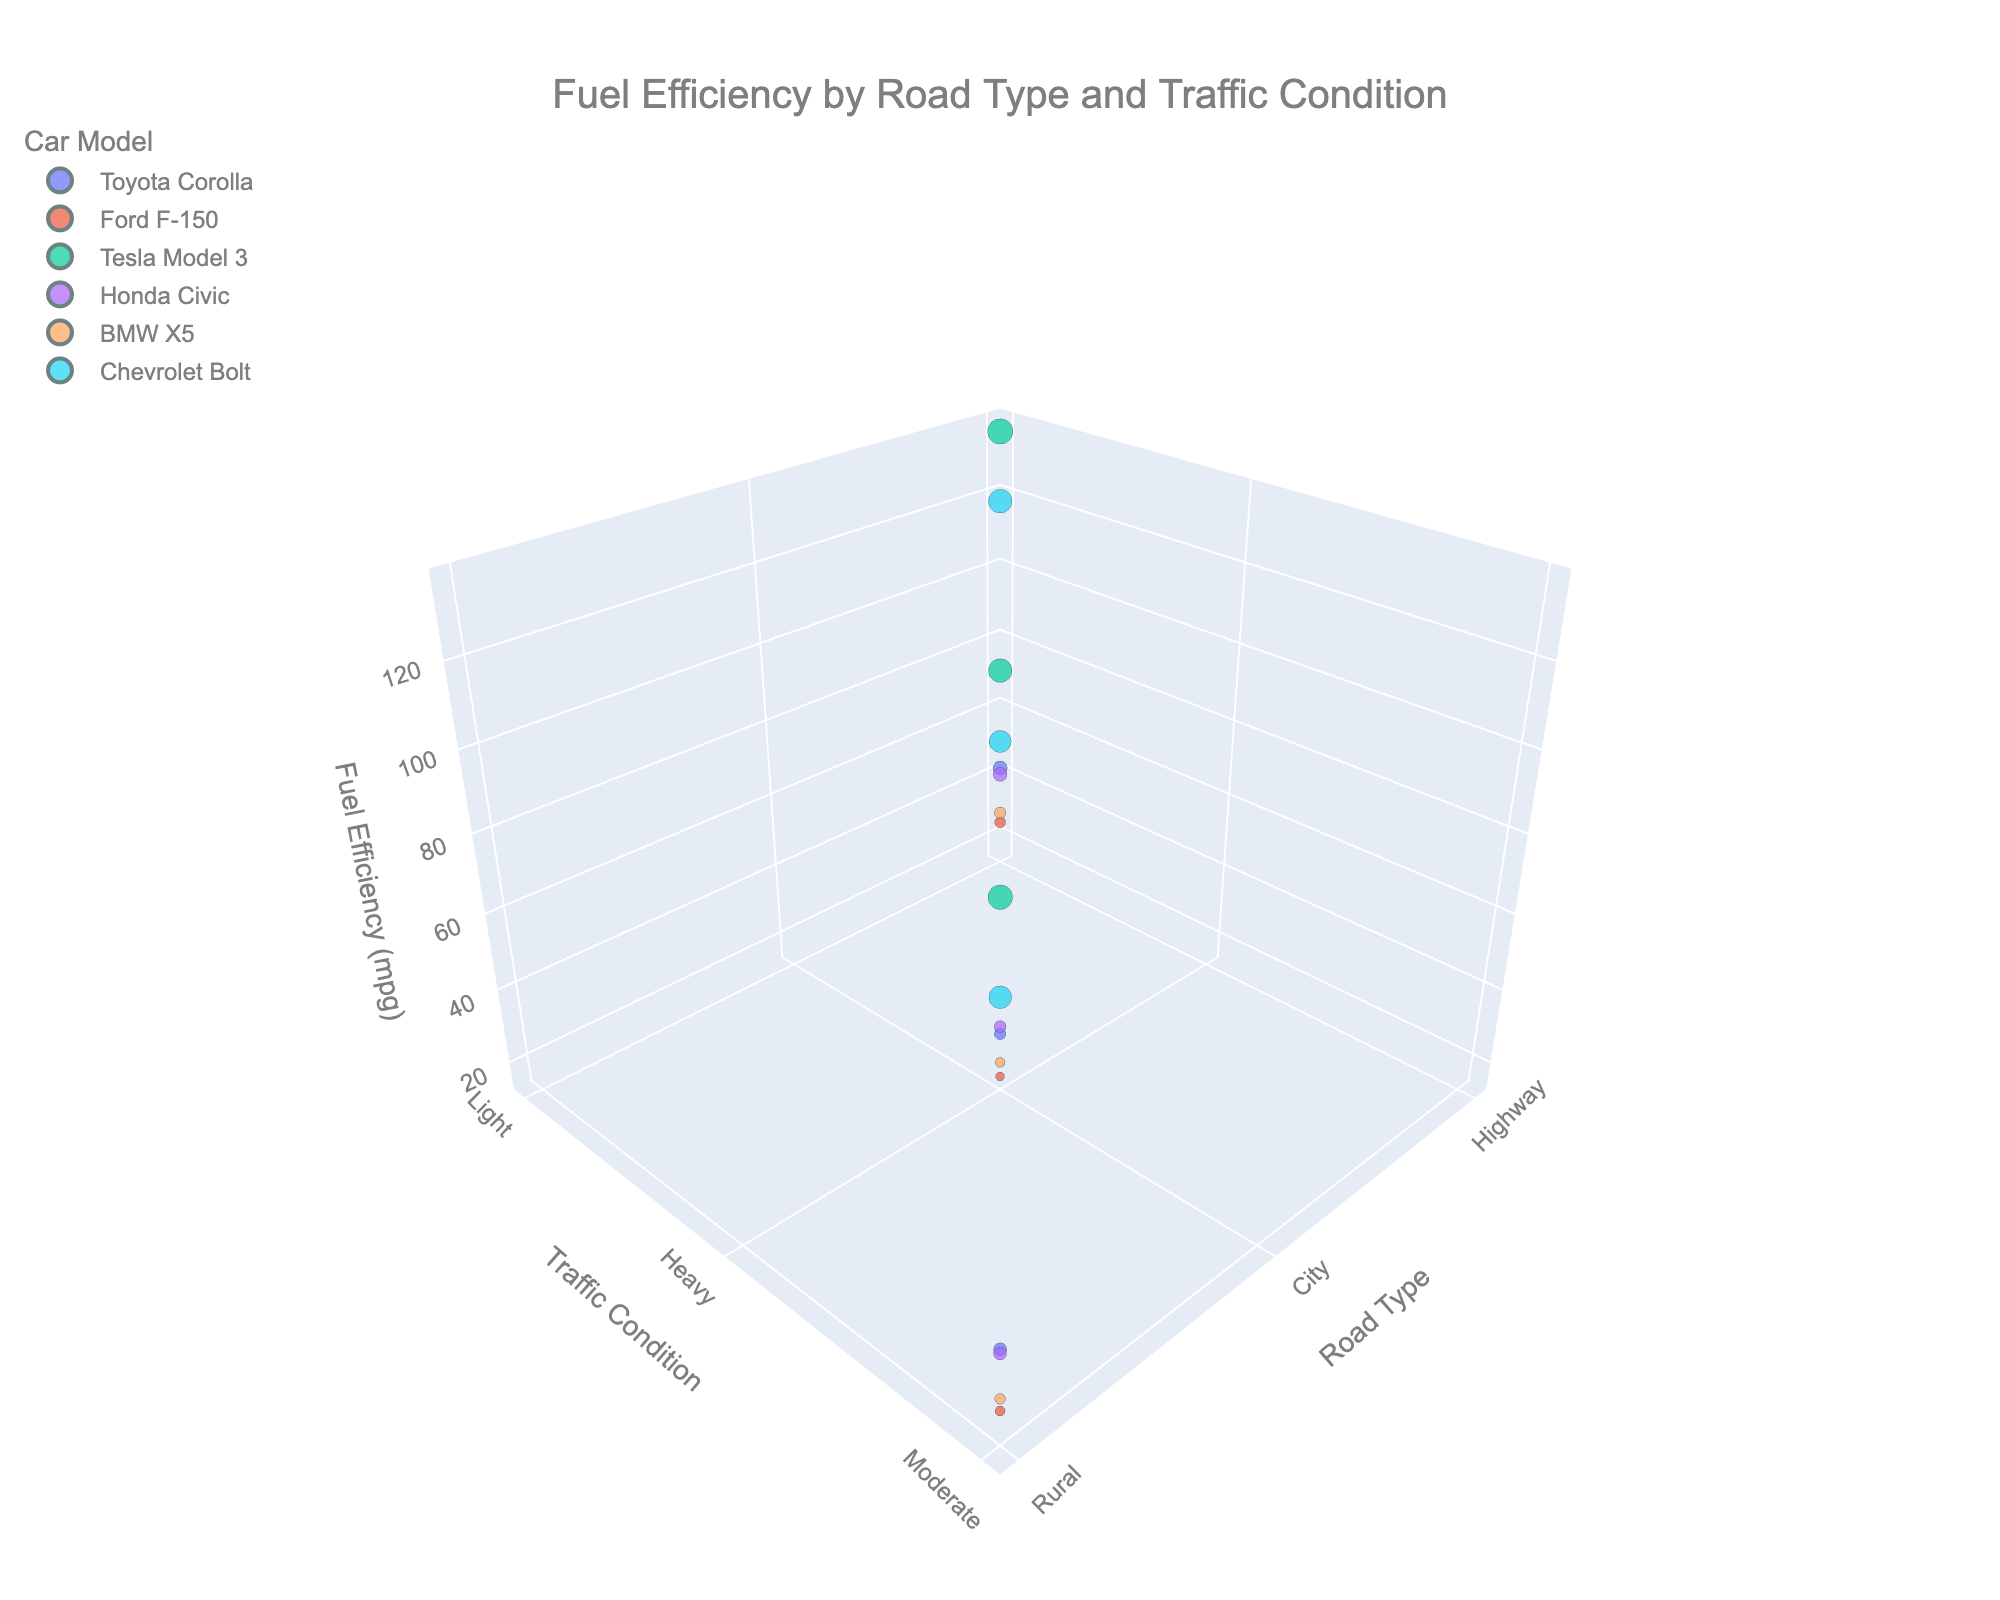What is the title of the plot? The title of the plot is usually placed at the top of the figure. In this case, you can read the title at the top.
Answer: Fuel Efficiency by Road Type and Traffic Condition How does the fuel efficiency of the Tesla Model 3 compare between highway and city traffic conditions? Look for the points representing the Tesla Model 3. These points will show different fuel efficiencies for highway and city traffic conditions. You can see that on the highway with light traffic, the fuel efficiency is higher compared to the city with heavy traffic.
Answer: Higher on the highway Which car model has the lowest fuel efficiency in rural areas? Find points representing rural areas and compare the fuel efficiencies of different car models in these areas. You will notice that the Ford F-150 has a lower fuel efficiency compared to other models in rural conditions.
Answer: Ford F-150 What's the average fuel efficiency of the BMW X5 across all road types and traffic conditions? To calculate the average, add the fuel efficiencies of the BMW X5 for highway, city, and rural conditions, then divide by the number of conditions. BMW X5 fuel efficiencies are 28, 20, and 24 mpg, respectively. (28 + 20 + 24) / 3 = 72 / 3.
Answer: 24 mpg Which car model shows the greatest variation in fuel efficiency across different road types and traffic conditions? Identify the car models with the greatest range in fuel efficiency values by looking at the highest and lowest points for each model. The Tesla Model 3 has a large variation given its efficiency ranges from 118 to 136 mpg.
Answer: Tesla Model 3 Does any car model have the same fuel efficiency on two different road types? Look for data points where a car model's fuel efficiency is identical across different road types or traffic conditions. You will see that no car model has identical fuel efficiencies across different road types and traffic conditions.
Answer: No Compare the fuel efficiency of Honda Civic and Toyota Corolla on city roads with heavy traffic conditions. Look at the points for Honda Civic and Toyota Corolla under city roads with heavy traffic and compare their fuel efficiencies. Honda Civic shows 30 mpg, whereas Toyota Corolla shows 28 mpg.
Answer: Higher for Honda Civic Which road type generally provides the best fuel efficiency for most car models? Compare the fuel efficiency of cars across various road types by observing the z-axis elevation for each road type. Note that for most car models, highway conditions exhibit higher fuel efficiencies.
Answer: Highway What is the range of fuel efficiencies of electric cars (Tesla Model 3 and Chevrolet Bolt) on rural roads with moderate traffic? Identify the fuel efficiencies of the Tesla Model 3 and Chevrolet Bolt under rural roads. Tesla Model 3 has 128 mpg and Chevrolet Bolt has 110 mpg. The range is the difference between the highest and lowest value. 128 - 110.
Answer: 18 mpg Are electric cars consistently more fuel-efficient than gasoline cars across all conditions in the plot? Compare the points representing electric cars (Tesla Model 3, Chevrolet Bolt) and gasoline cars (all others) across all conditions. Notice that electric cars always have higher fuel efficiency values than gasoline cars across all road types and traffic conditions.
Answer: Yes 